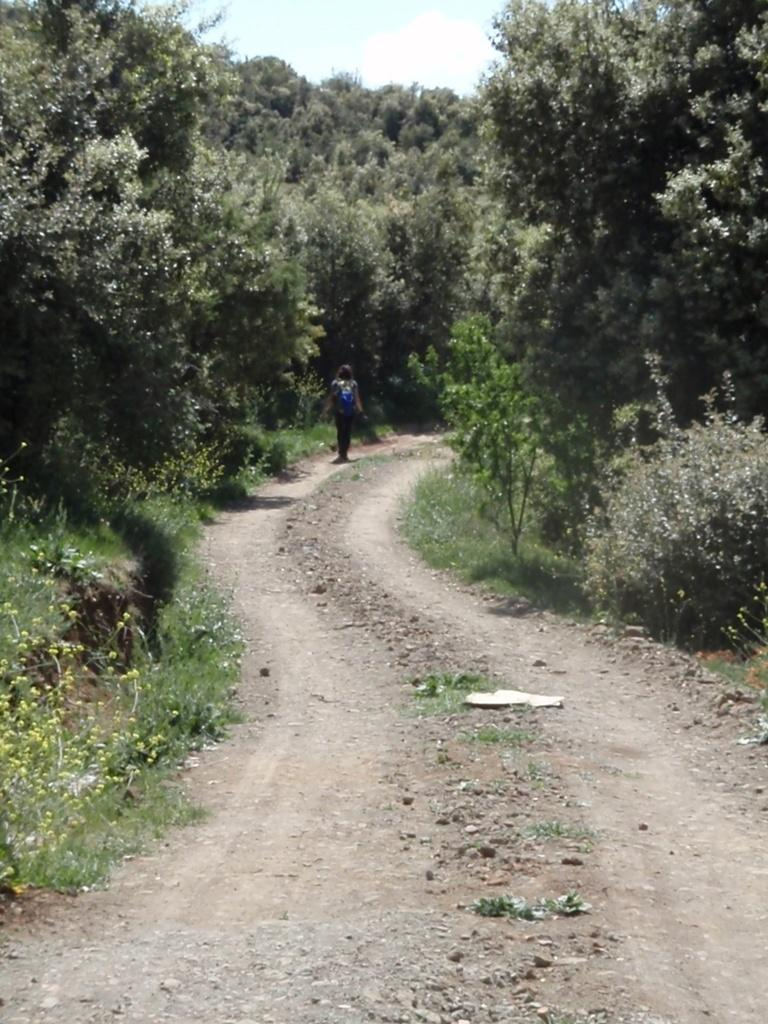What can be seen beneath the person in the image? The ground is visible in the image. What is the person doing in the image? There is a person walking on the ground. What type of vegetation is near the person? There are many trees near the person. What is visible in the distance behind the person? The sky is visible in the background of the image. What type of flame can be seen burning near the trees in the image? There is no flame present in the image; it features a person walking on the ground near trees. What scientific fact can be observed in the image? The image does not depict a specific scientific fact; it shows a person walking on the ground near trees with the sky visible in the background. 